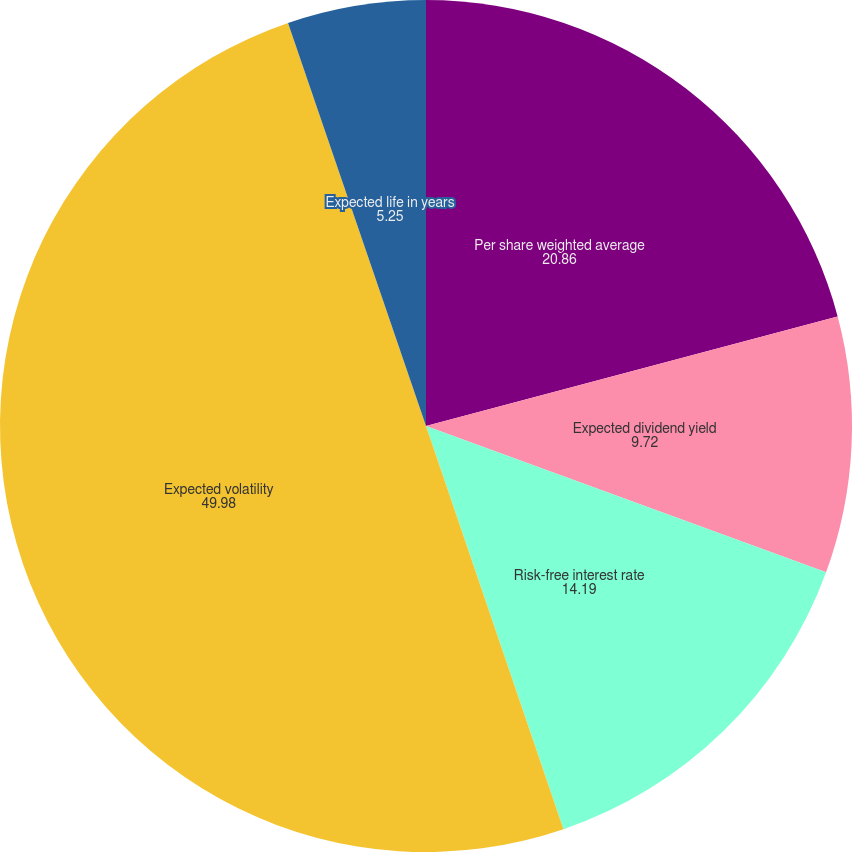Convert chart to OTSL. <chart><loc_0><loc_0><loc_500><loc_500><pie_chart><fcel>Per share weighted average<fcel>Expected dividend yield<fcel>Risk-free interest rate<fcel>Expected volatility<fcel>Expected life in years<nl><fcel>20.86%<fcel>9.72%<fcel>14.19%<fcel>49.98%<fcel>5.25%<nl></chart> 